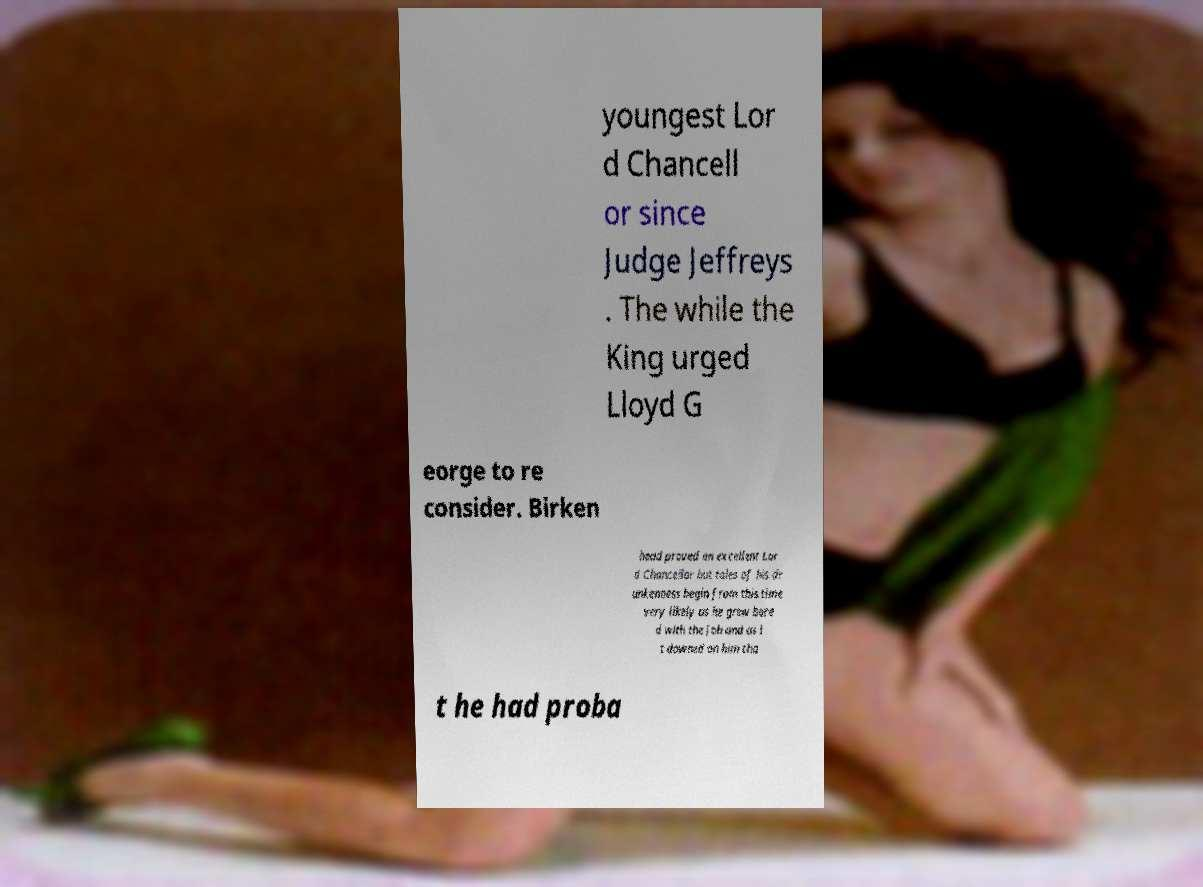What messages or text are displayed in this image? I need them in a readable, typed format. youngest Lor d Chancell or since Judge Jeffreys . The while the King urged Lloyd G eorge to re consider. Birken head proved an excellent Lor d Chancellor but tales of his dr unkenness begin from this time very likely as he grew bore d with the job and as i t dawned on him tha t he had proba 